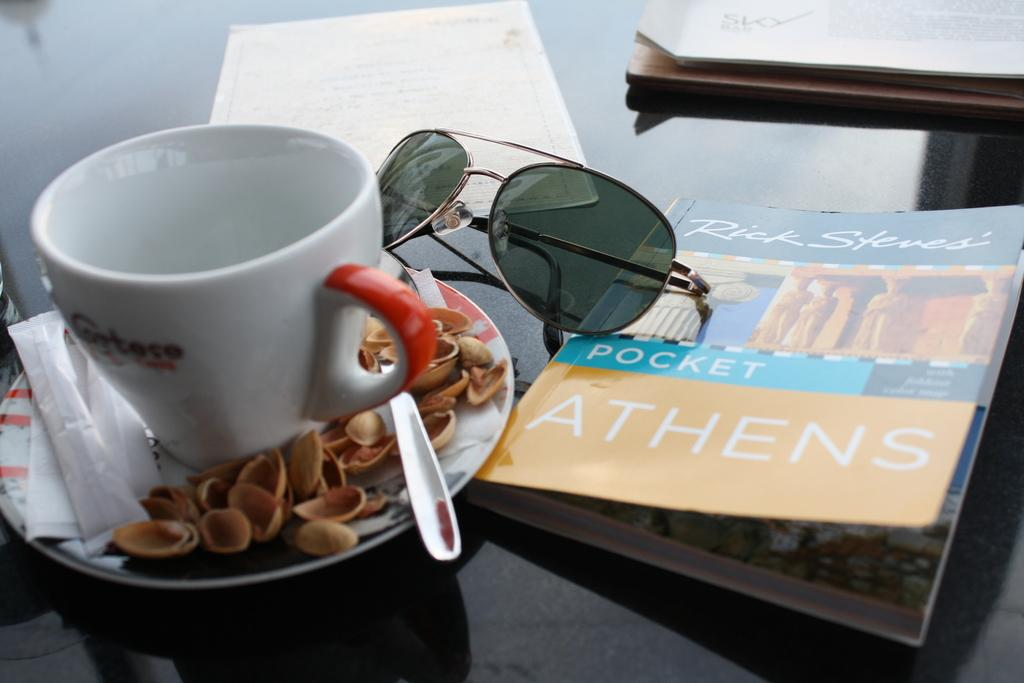What is one object in the image that might be used for reading? There is a book in the image that might be used for reading. What is another object in the image that might be used for a different activity? There are goggles in the image that might be used for activities like swimming or skiing. What items in the image might be related to writing or note-taking? There are papers and sugar packets in the image that might be related to writing or note-taking. What objects in the image might be used for eating or drinking? There is a cup and saucer, a spoon, and sugar packets in the image that might be used for eating or drinking. What is the only item in the image that indicates a snack has been consumed? There is a pistachio peel in the image that indicates a snack has been consumed. What type of soup can be seen in the image? There is no soup present in the image. What is the wind doing to the goggles in the image? There is no wind present in the image, and the goggles are not affected by any wind. 